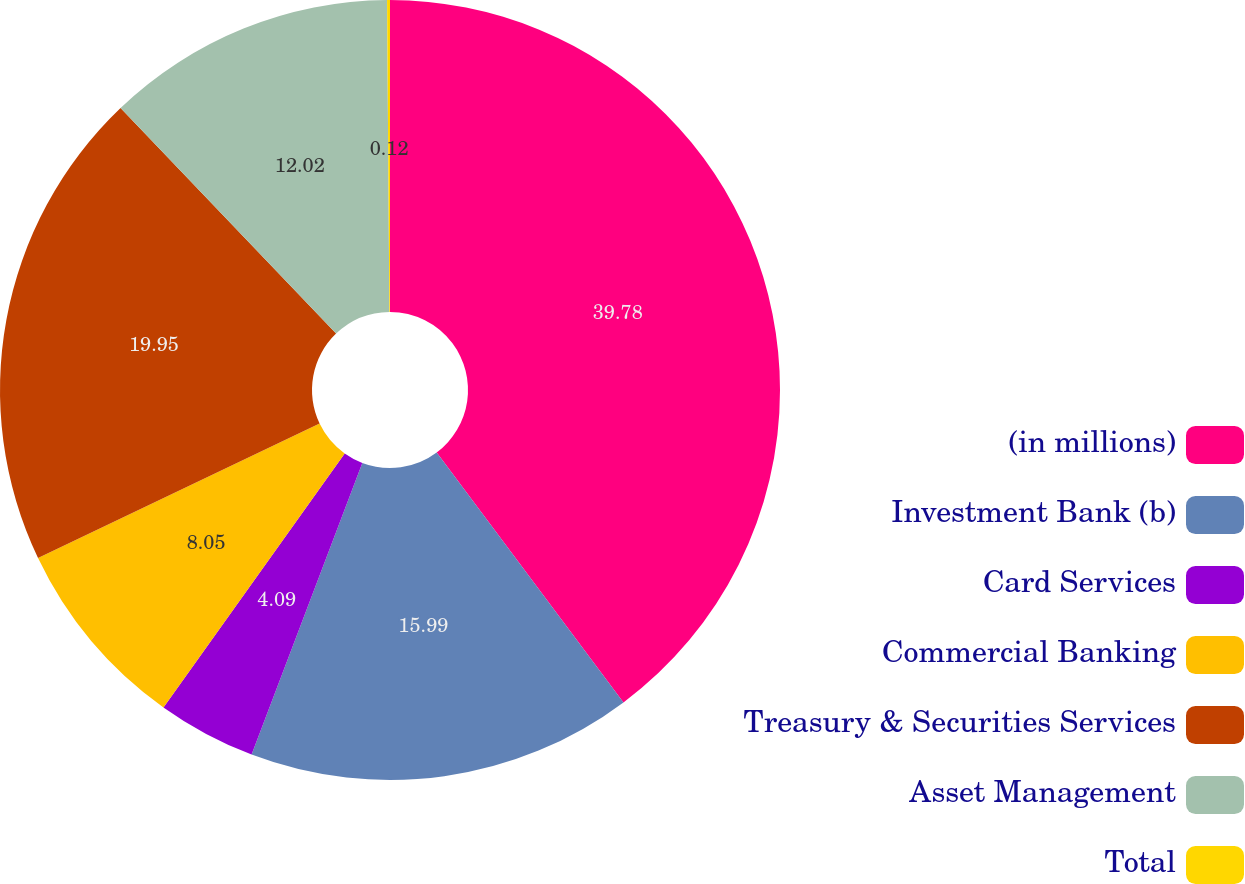<chart> <loc_0><loc_0><loc_500><loc_500><pie_chart><fcel>(in millions)<fcel>Investment Bank (b)<fcel>Card Services<fcel>Commercial Banking<fcel>Treasury & Securities Services<fcel>Asset Management<fcel>Total<nl><fcel>39.79%<fcel>15.99%<fcel>4.09%<fcel>8.05%<fcel>19.95%<fcel>12.02%<fcel>0.12%<nl></chart> 